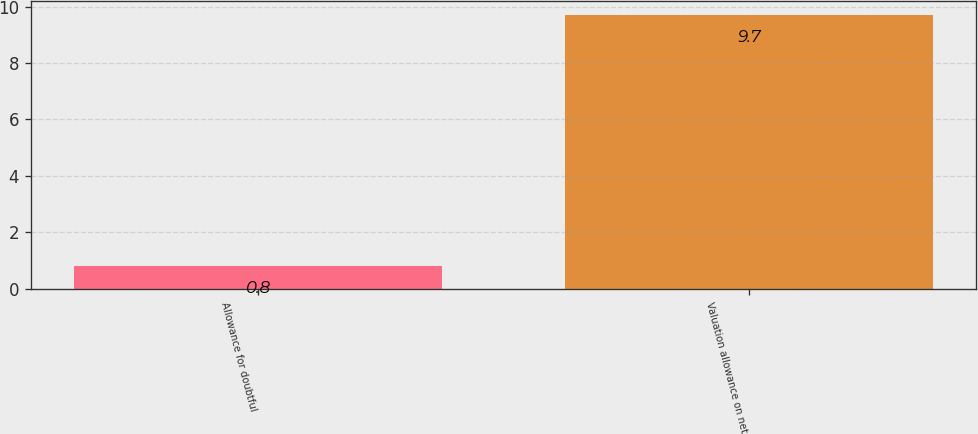Convert chart. <chart><loc_0><loc_0><loc_500><loc_500><bar_chart><fcel>Allowance for doubtful<fcel>Valuation allowance on net<nl><fcel>0.8<fcel>9.7<nl></chart> 